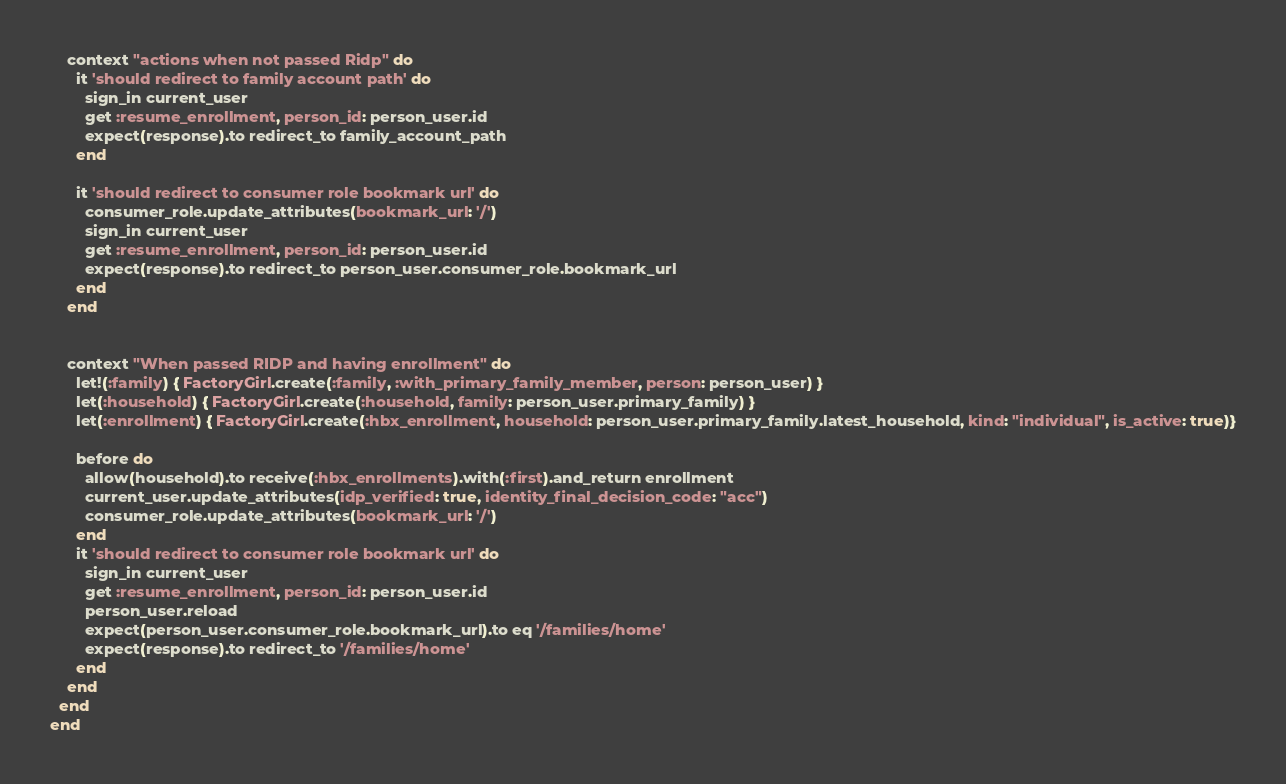Convert code to text. <code><loc_0><loc_0><loc_500><loc_500><_Ruby_>    context "actions when not passed Ridp" do
      it 'should redirect to family account path' do
        sign_in current_user
        get :resume_enrollment, person_id: person_user.id
        expect(response).to redirect_to family_account_path
      end

      it 'should redirect to consumer role bookmark url' do
        consumer_role.update_attributes(bookmark_url: '/')
        sign_in current_user
        get :resume_enrollment, person_id: person_user.id
        expect(response).to redirect_to person_user.consumer_role.bookmark_url
      end
    end


    context "When passed RIDP and having enrollment" do
      let!(:family) { FactoryGirl.create(:family, :with_primary_family_member, person: person_user) }
      let(:household) { FactoryGirl.create(:household, family: person_user.primary_family) }
      let(:enrollment) { FactoryGirl.create(:hbx_enrollment, household: person_user.primary_family.latest_household, kind: "individual", is_active: true)}

      before do
        allow(household).to receive(:hbx_enrollments).with(:first).and_return enrollment
        current_user.update_attributes(idp_verified: true, identity_final_decision_code: "acc")
        consumer_role.update_attributes(bookmark_url: '/')
      end
      it 'should redirect to consumer role bookmark url' do
        sign_in current_user
        get :resume_enrollment, person_id: person_user.id
        person_user.reload
        expect(person_user.consumer_role.bookmark_url).to eq '/families/home'
        expect(response).to redirect_to '/families/home'
      end
    end
  end
end
</code> 